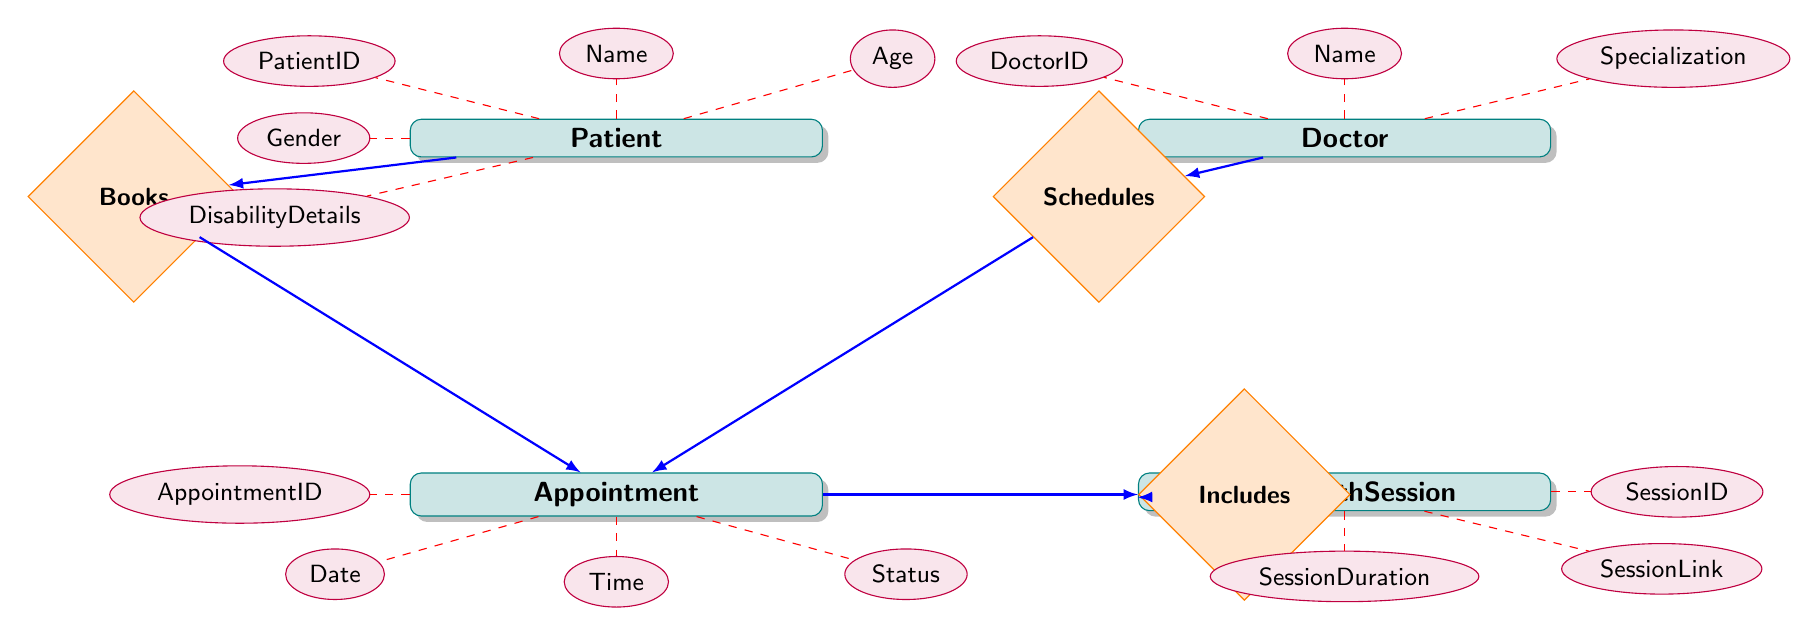What's the total number of entities in the diagram? There are four entities present in the diagram: Patient, Doctor, Appointment, and TelehealthSession.
Answer: 4 What is the relationship between Doctor and Appointment? The relationship between Doctor and Appointment is labeled as "Schedules," indicating a one-to-many relationship; each doctor can schedule multiple appointments.
Answer: Schedules How many attributes does the Patient entity have? The Patient entity has six attributes: PatientID, Name, Age, Gender, DisabilityDetails, and ContactNumber.
Answer: 6 What type of relationship is established between Appointment and TelehealthSession? The relationship between Appointment and TelehealthSession is labeled as "Includes," indicating a one-to-one relationship; each appointment includes one telehealth session.
Answer: Includes Which attribute is associated with the Doctor entity? The attributes associated with the Doctor entity include DoctorID, Name, Specialization, ContactNumber, and EmailAddress.
Answer: DoctorID, Name, Specialization, ContactNumber, EmailAddress What is the nature of the relationship between Patient and Appointment? The relationship between Patient and Appointment is indicated as "Books," suggesting a one-to-many relationship; a patient can book multiple appointments.
Answer: Books What is the SessionLink in relation to TelehealthSession? The SessionLink is an attribute of the TelehealthSession entity that provides a link for accessing the telehealth session.
Answer: SessionLink Which entity includes the disability details of the patient? The disability details are included in the attributes of the Patient entity, specifically indicated by DisabilityDetails.
Answer: Patient What is the maximum number of appointments a single doctor can have? Since the relationship "Schedules" between Doctor and Appointment is one-to-many, a single doctor can have an unlimited number of appointments.
Answer: Unlimited How many relationships are defined in this diagram? There are three relationships defined in the diagram: Schedules, Books, and Includes, connecting the entities together.
Answer: 3 